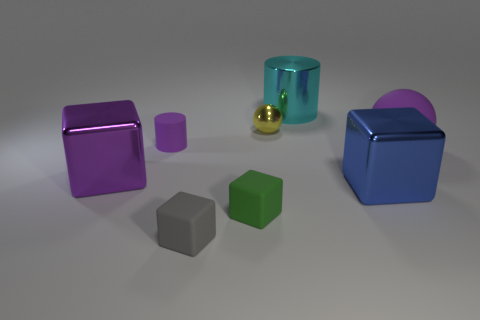There is a cylinder that is the same size as the rubber ball; what color is it? cyan 